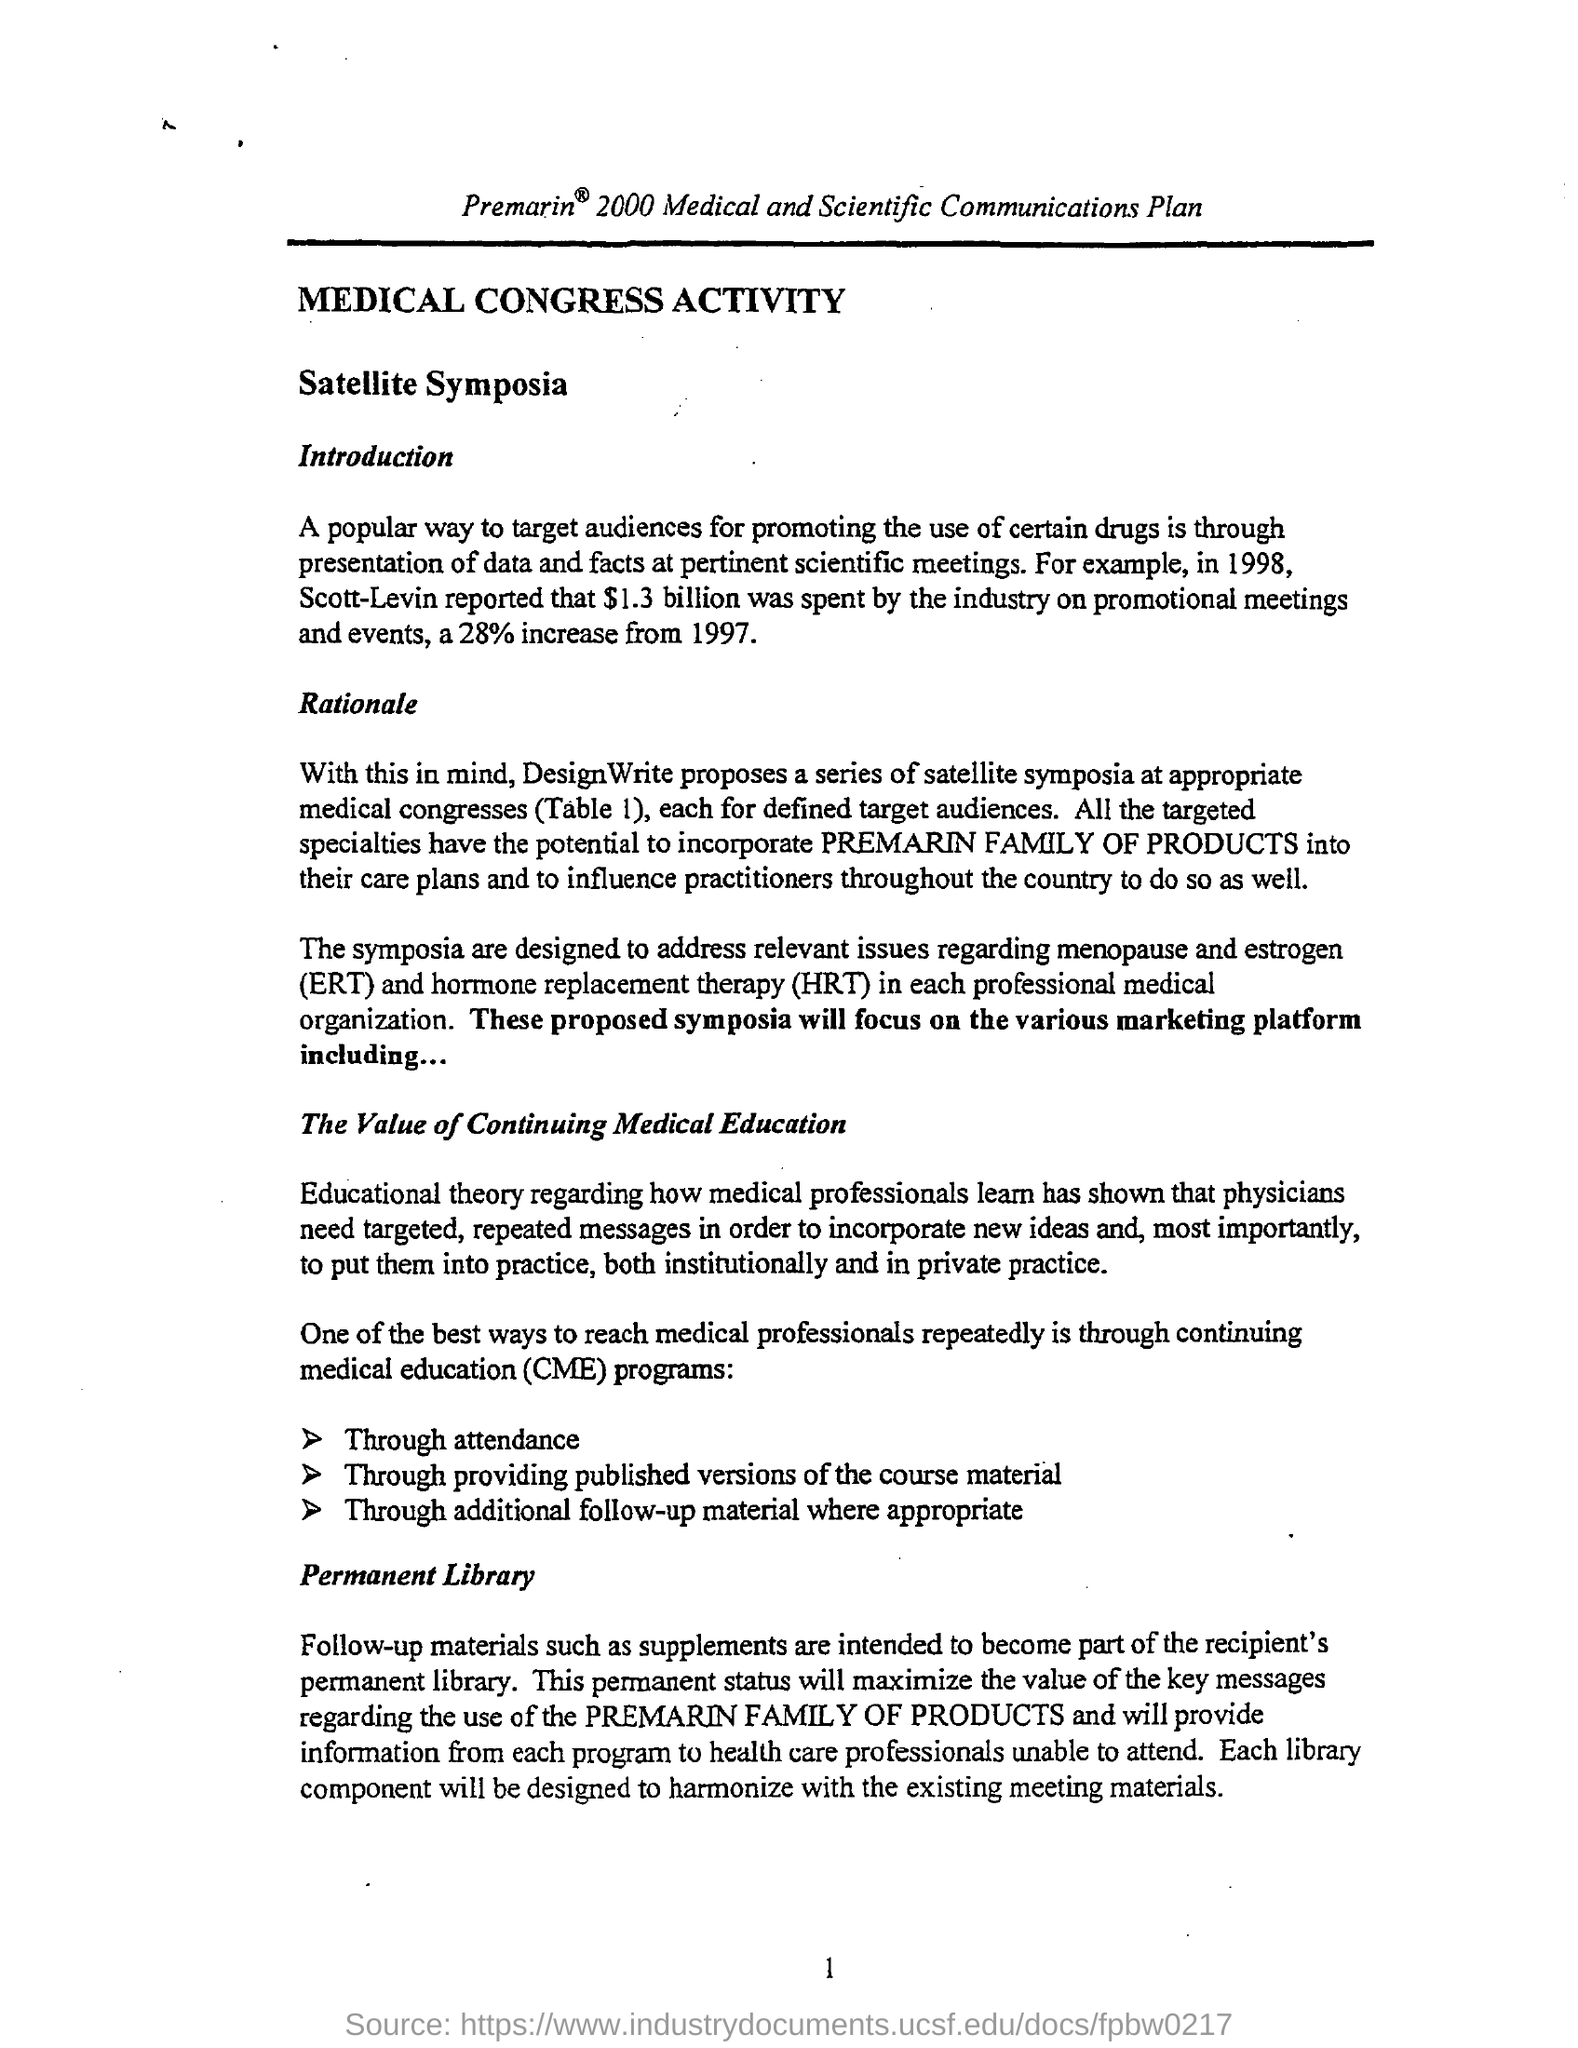Highlight a few significant elements in this photo. Hormone replacement therapy (HRT) is a medical treatment in which hormones are administered to replace those that are no longer being produced by the body. The company hosts a series of satellite symposia at medical congresses, targeting specific audiences as outlined in Table 1. The recipient's permanent library should consist of materials that are intended to become a lasting part of their collection, including follow-up materials such as supplements. 